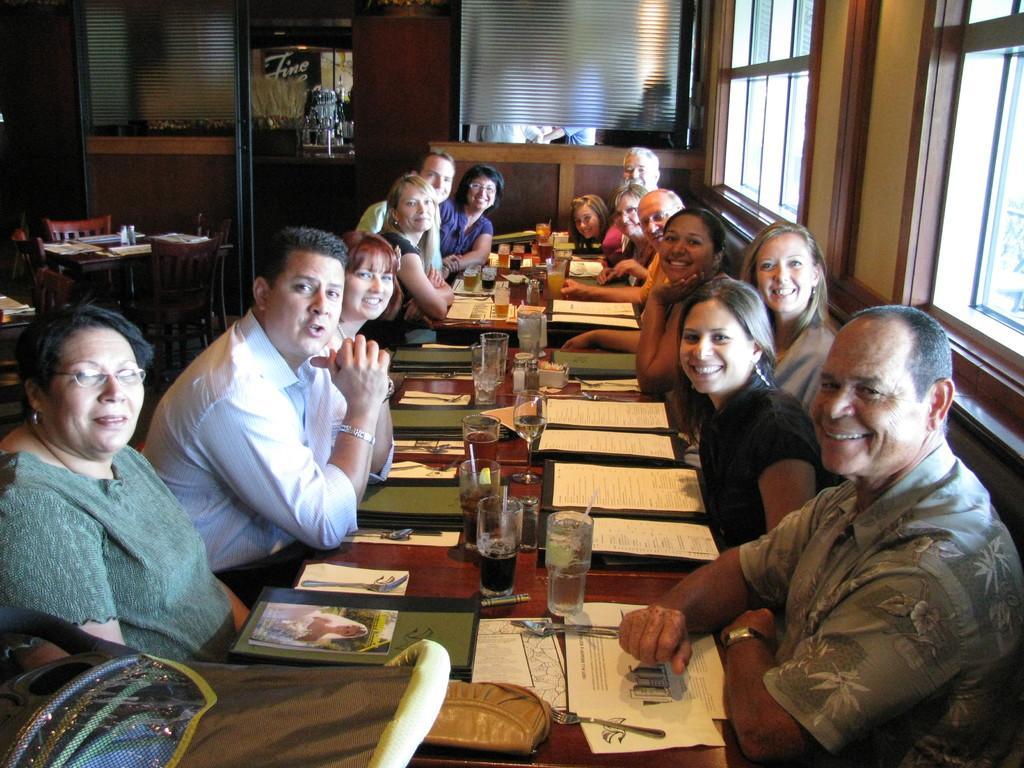Please provide a concise description of this image. In this image we can see people are sitting around the table. We can see glasses, spoons, forks, menu cards and bag on the table. In the background we can see glass windows. 